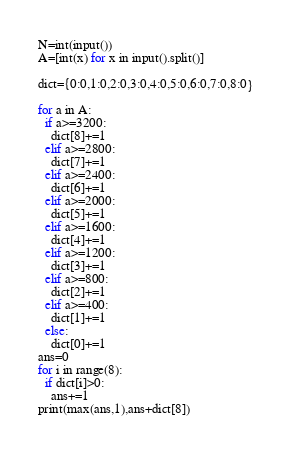<code> <loc_0><loc_0><loc_500><loc_500><_Python_>N=int(input())
A=[int(x) for x in input().split()]

dict={0:0,1:0,2:0,3:0,4:0,5:0,6:0,7:0,8:0}

for a in A:
  if a>=3200:
    dict[8]+=1
  elif a>=2800:
    dict[7]+=1
  elif a>=2400:
    dict[6]+=1
  elif a>=2000:
    dict[5]+=1
  elif a>=1600:
    dict[4]+=1
  elif a>=1200:
    dict[3]+=1
  elif a>=800:
    dict[2]+=1
  elif a>=400:
    dict[1]+=1
  else:
    dict[0]+=1
ans=0
for i in range(8):
  if dict[i]>0:
    ans+=1
print(max(ans,1),ans+dict[8])</code> 